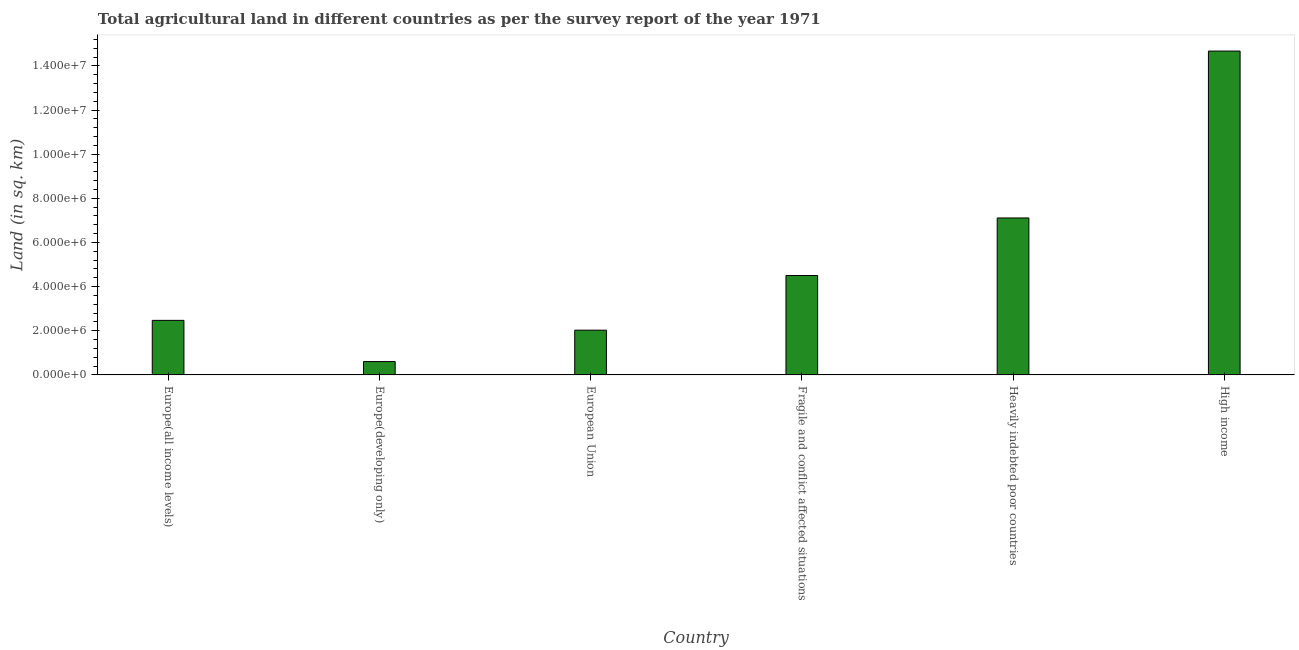Does the graph contain any zero values?
Provide a short and direct response. No. What is the title of the graph?
Provide a succinct answer. Total agricultural land in different countries as per the survey report of the year 1971. What is the label or title of the X-axis?
Offer a terse response. Country. What is the label or title of the Y-axis?
Offer a terse response. Land (in sq. km). What is the agricultural land in High income?
Make the answer very short. 1.47e+07. Across all countries, what is the maximum agricultural land?
Ensure brevity in your answer.  1.47e+07. Across all countries, what is the minimum agricultural land?
Make the answer very short. 6.05e+05. In which country was the agricultural land maximum?
Offer a very short reply. High income. In which country was the agricultural land minimum?
Offer a very short reply. Europe(developing only). What is the sum of the agricultural land?
Make the answer very short. 3.14e+07. What is the difference between the agricultural land in Fragile and conflict affected situations and Heavily indebted poor countries?
Keep it short and to the point. -2.61e+06. What is the average agricultural land per country?
Give a very brief answer. 5.23e+06. What is the median agricultural land?
Keep it short and to the point. 3.49e+06. What is the ratio of the agricultural land in European Union to that in Fragile and conflict affected situations?
Offer a terse response. 0.45. Is the agricultural land in Heavily indebted poor countries less than that in High income?
Keep it short and to the point. Yes. What is the difference between the highest and the second highest agricultural land?
Provide a short and direct response. 7.56e+06. What is the difference between the highest and the lowest agricultural land?
Offer a very short reply. 1.41e+07. How many bars are there?
Your answer should be very brief. 6. How many countries are there in the graph?
Offer a very short reply. 6. What is the difference between two consecutive major ticks on the Y-axis?
Provide a succinct answer. 2.00e+06. Are the values on the major ticks of Y-axis written in scientific E-notation?
Provide a short and direct response. Yes. What is the Land (in sq. km) in Europe(all income levels)?
Provide a succinct answer. 2.47e+06. What is the Land (in sq. km) of Europe(developing only)?
Offer a terse response. 6.05e+05. What is the Land (in sq. km) in European Union?
Ensure brevity in your answer.  2.03e+06. What is the Land (in sq. km) in Fragile and conflict affected situations?
Make the answer very short. 4.50e+06. What is the Land (in sq. km) of Heavily indebted poor countries?
Provide a short and direct response. 7.11e+06. What is the Land (in sq. km) of High income?
Provide a succinct answer. 1.47e+07. What is the difference between the Land (in sq. km) in Europe(all income levels) and Europe(developing only)?
Give a very brief answer. 1.87e+06. What is the difference between the Land (in sq. km) in Europe(all income levels) and European Union?
Offer a very short reply. 4.44e+05. What is the difference between the Land (in sq. km) in Europe(all income levels) and Fragile and conflict affected situations?
Offer a very short reply. -2.03e+06. What is the difference between the Land (in sq. km) in Europe(all income levels) and Heavily indebted poor countries?
Ensure brevity in your answer.  -4.64e+06. What is the difference between the Land (in sq. km) in Europe(all income levels) and High income?
Give a very brief answer. -1.22e+07. What is the difference between the Land (in sq. km) in Europe(developing only) and European Union?
Give a very brief answer. -1.42e+06. What is the difference between the Land (in sq. km) in Europe(developing only) and Fragile and conflict affected situations?
Give a very brief answer. -3.90e+06. What is the difference between the Land (in sq. km) in Europe(developing only) and Heavily indebted poor countries?
Offer a very short reply. -6.51e+06. What is the difference between the Land (in sq. km) in Europe(developing only) and High income?
Give a very brief answer. -1.41e+07. What is the difference between the Land (in sq. km) in European Union and Fragile and conflict affected situations?
Offer a very short reply. -2.48e+06. What is the difference between the Land (in sq. km) in European Union and Heavily indebted poor countries?
Your response must be concise. -5.08e+06. What is the difference between the Land (in sq. km) in European Union and High income?
Keep it short and to the point. -1.26e+07. What is the difference between the Land (in sq. km) in Fragile and conflict affected situations and Heavily indebted poor countries?
Ensure brevity in your answer.  -2.61e+06. What is the difference between the Land (in sq. km) in Fragile and conflict affected situations and High income?
Your answer should be compact. -1.02e+07. What is the difference between the Land (in sq. km) in Heavily indebted poor countries and High income?
Your answer should be very brief. -7.56e+06. What is the ratio of the Land (in sq. km) in Europe(all income levels) to that in Europe(developing only)?
Provide a short and direct response. 4.09. What is the ratio of the Land (in sq. km) in Europe(all income levels) to that in European Union?
Give a very brief answer. 1.22. What is the ratio of the Land (in sq. km) in Europe(all income levels) to that in Fragile and conflict affected situations?
Your answer should be compact. 0.55. What is the ratio of the Land (in sq. km) in Europe(all income levels) to that in Heavily indebted poor countries?
Make the answer very short. 0.35. What is the ratio of the Land (in sq. km) in Europe(all income levels) to that in High income?
Offer a terse response. 0.17. What is the ratio of the Land (in sq. km) in Europe(developing only) to that in European Union?
Offer a very short reply. 0.3. What is the ratio of the Land (in sq. km) in Europe(developing only) to that in Fragile and conflict affected situations?
Provide a short and direct response. 0.13. What is the ratio of the Land (in sq. km) in Europe(developing only) to that in Heavily indebted poor countries?
Keep it short and to the point. 0.09. What is the ratio of the Land (in sq. km) in Europe(developing only) to that in High income?
Provide a succinct answer. 0.04. What is the ratio of the Land (in sq. km) in European Union to that in Fragile and conflict affected situations?
Provide a short and direct response. 0.45. What is the ratio of the Land (in sq. km) in European Union to that in Heavily indebted poor countries?
Offer a terse response. 0.28. What is the ratio of the Land (in sq. km) in European Union to that in High income?
Your answer should be compact. 0.14. What is the ratio of the Land (in sq. km) in Fragile and conflict affected situations to that in Heavily indebted poor countries?
Provide a succinct answer. 0.63. What is the ratio of the Land (in sq. km) in Fragile and conflict affected situations to that in High income?
Your answer should be compact. 0.31. What is the ratio of the Land (in sq. km) in Heavily indebted poor countries to that in High income?
Your answer should be compact. 0.48. 